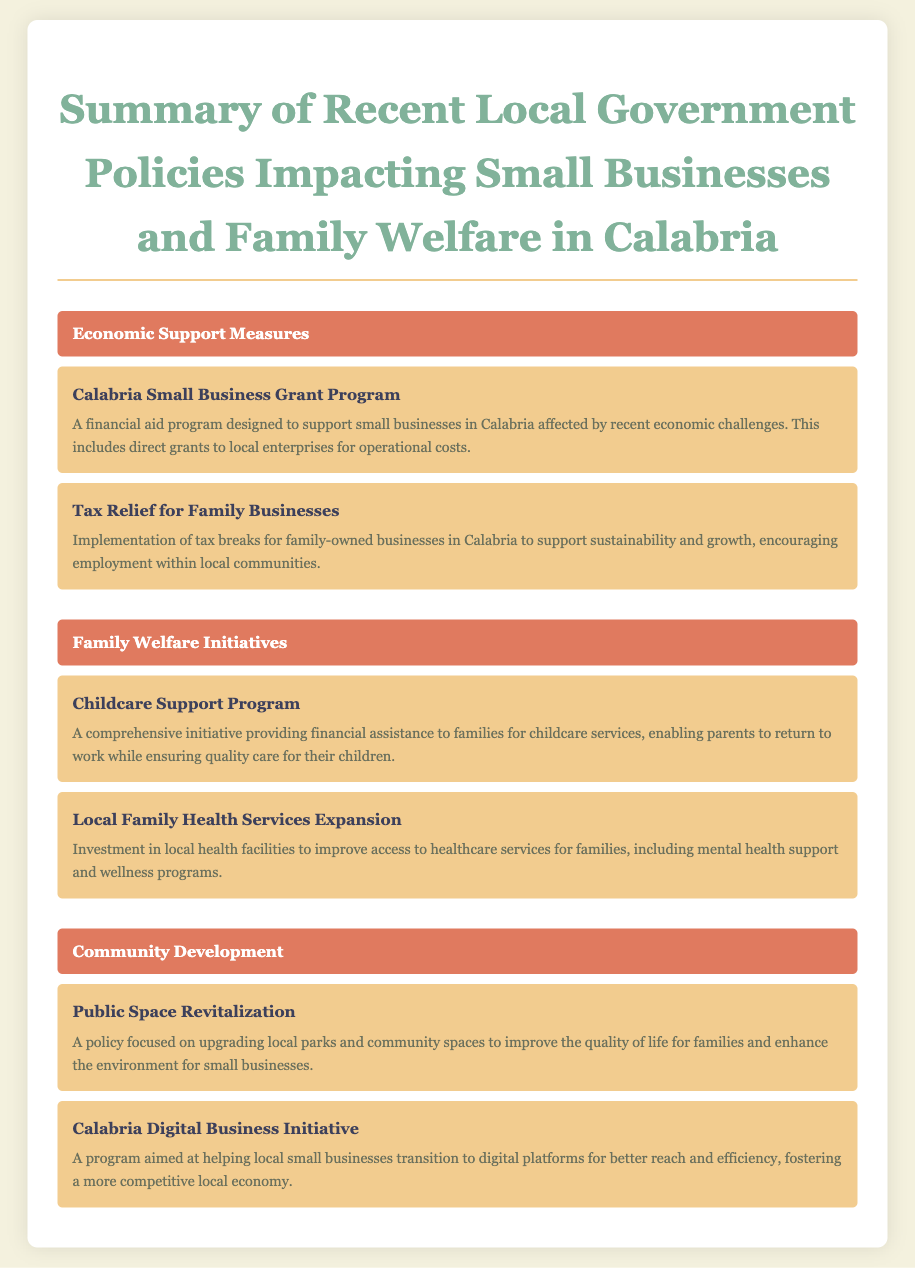What is the name of the financial aid program for small businesses? The name of the financial aid program is mentioned under Economic Support Measures and is specifically designed to assist small businesses in Calabria.
Answer: Calabria Small Business Grant Program What initiative provides financial assistance for childcare services? This initiative can be found under Family Welfare Initiatives and is designed to support families with childcare expenses.
Answer: Childcare Support Program Which program targets tax relief for family-owned businesses? The document lists this program which aims to support family businesses in Calabria through tax breaks.
Answer: Tax Relief for Family Businesses How does the Local Family Health Services Expansion benefit families? The benefit provided by this initiative focuses on improving access to healthcare services for families in Calabria.
Answer: Access to healthcare services Which policy aims to improve local parks and community spaces? This policy is categorized under Community Development and focuses on enhancing the environment for families and small businesses.
Answer: Public Space Revitalization What is the goal of the Calabria Digital Business Initiative? The goal identified in the document is to help small businesses transition to digital platforms.
Answer: Transition to digital platforms How many policies are listed in the Family Welfare Initiatives section? The document provides two specific policies focused on family welfare, as listed under that section.
Answer: Two What type of tax incentives are mentioned for family businesses? The document outlines specific tax incentives that are implemented to encourage sustainability and growth for family businesses.
Answer: Tax breaks What is a primary goal of the Calabria Small Business Grant Program? The primary goal mentioned in the document is to support small businesses affected by economic challenges.
Answer: Support small businesses 